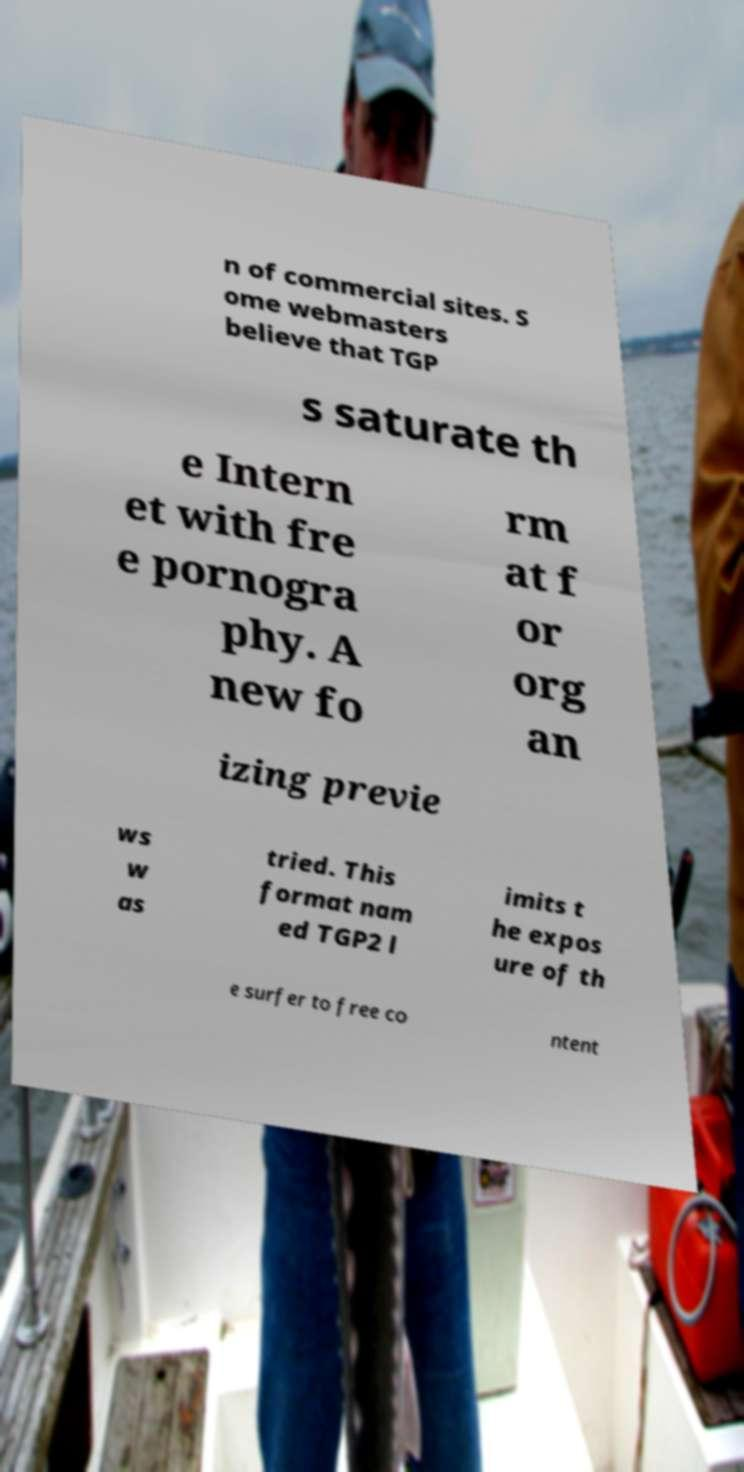Please identify and transcribe the text found in this image. n of commercial sites. S ome webmasters believe that TGP s saturate th e Intern et with fre e pornogra phy. A new fo rm at f or org an izing previe ws w as tried. This format nam ed TGP2 l imits t he expos ure of th e surfer to free co ntent 